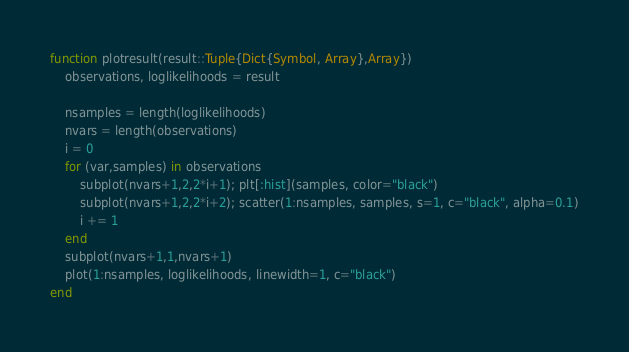<code> <loc_0><loc_0><loc_500><loc_500><_Julia_>
function plotresult(result::Tuple{Dict{Symbol, Array},Array})
    observations, loglikelihoods = result

    nsamples = length(loglikelihoods)
    nvars = length(observations)
    i = 0
    for (var,samples) in observations
        subplot(nvars+1,2,2*i+1); plt[:hist](samples, color="black")
        subplot(nvars+1,2,2*i+2); scatter(1:nsamples, samples, s=1, c="black", alpha=0.1)
        i += 1
    end
    subplot(nvars+1,1,nvars+1)
    plot(1:nsamples, loglikelihoods, linewidth=1, c="black")
end
</code> 